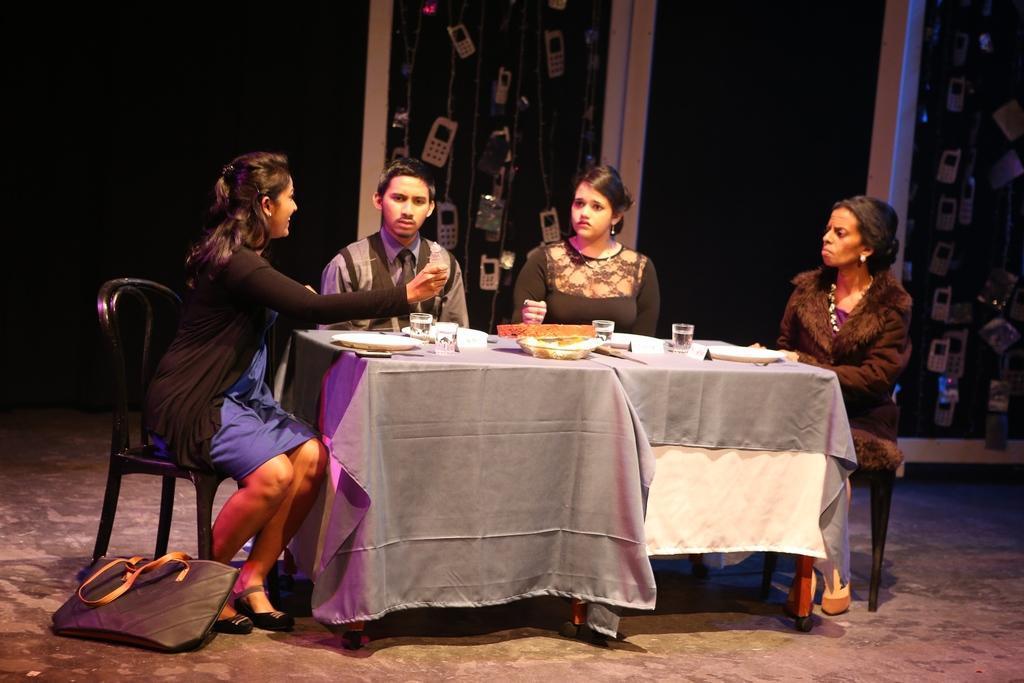Can you describe this image briefly? In this image there are group of persons who are sitting around the table and there are plates,glasses on top of the table at the left side of the image there is a bag on the floor and at the background of the image there is a wall. 